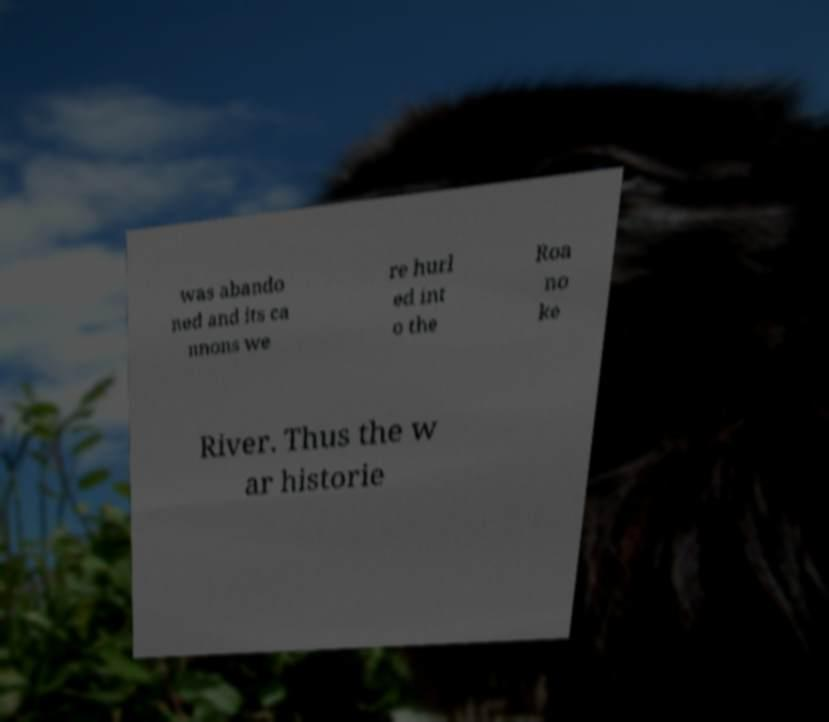Please read and relay the text visible in this image. What does it say? was abando ned and its ca nnons we re hurl ed int o the Roa no ke River. Thus the w ar historie 